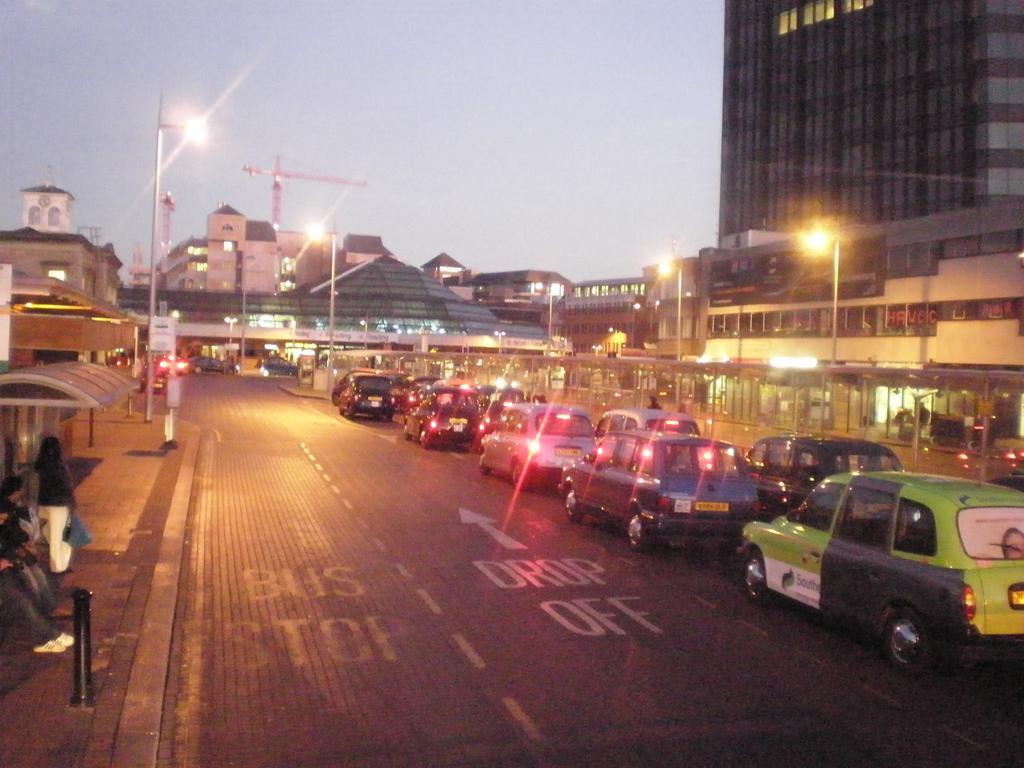Could you give a brief overview of what you see in this image? In this image I can see a road in the centre and on it I can see number of vehicles. I can also see something is written on the road. On the both sides of the road, I can see number of poles, street lights, number of buildings and on the left side of the image I can see a white colour board on the one pole. On the bottom left side of the image, I can see three persons on the footpath and in the background I can see the sky. 